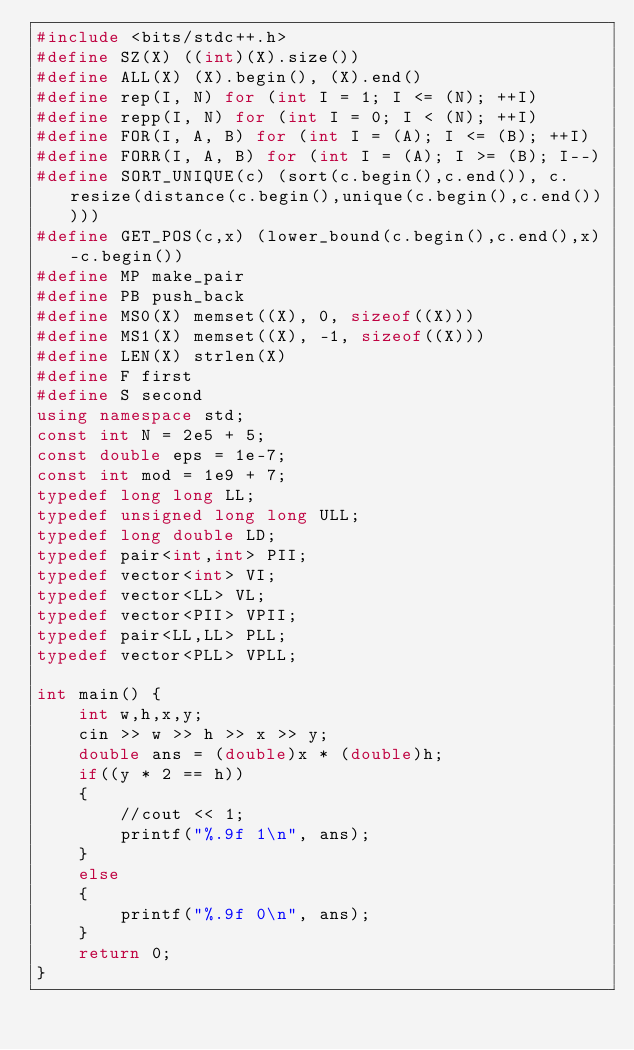Convert code to text. <code><loc_0><loc_0><loc_500><loc_500><_C++_>#include <bits/stdc++.h>
#define SZ(X) ((int)(X).size())
#define ALL(X) (X).begin(), (X).end()
#define rep(I, N) for (int I = 1; I <= (N); ++I)
#define repp(I, N) for (int I = 0; I < (N); ++I)
#define FOR(I, A, B) for (int I = (A); I <= (B); ++I)
#define FORR(I, A, B) for (int I = (A); I >= (B); I--)
#define SORT_UNIQUE(c) (sort(c.begin(),c.end()), c.resize(distance(c.begin(),unique(c.begin(),c.end()))))
#define GET_POS(c,x) (lower_bound(c.begin(),c.end(),x)-c.begin())
#define MP make_pair
#define PB push_back
#define MS0(X) memset((X), 0, sizeof((X)))
#define MS1(X) memset((X), -1, sizeof((X)))
#define LEN(X) strlen(X)
#define F first
#define S second
using namespace std;
const int N = 2e5 + 5;
const double eps = 1e-7;
const int mod = 1e9 + 7;
typedef long long LL;
typedef unsigned long long ULL;
typedef long double LD;
typedef pair<int,int> PII;
typedef vector<int> VI;
typedef vector<LL> VL;
typedef vector<PII> VPII;
typedef pair<LL,LL> PLL;
typedef vector<PLL> VPLL;

int main() {
    int w,h,x,y;
    cin >> w >> h >> x >> y;
    double ans = (double)x * (double)h;
    if((y * 2 == h))
    {
        //cout << 1;
        printf("%.9f 1\n", ans);
    }
    else 
    {
        printf("%.9f 0\n", ans);
    }
    return 0;
}
</code> 